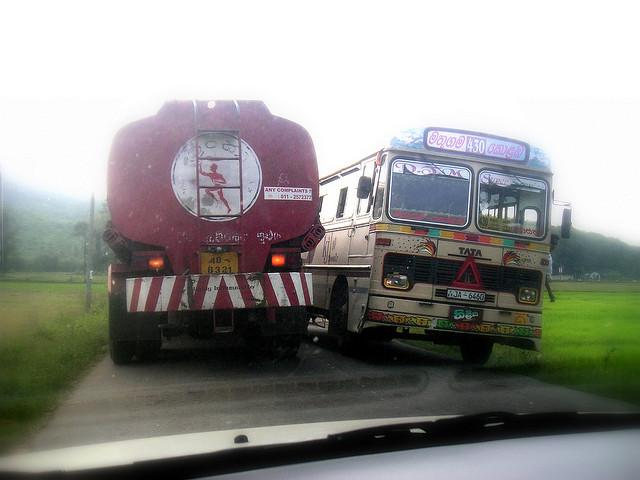Is this road wide enough for all vehicles present?
Be succinct. No. Where is the safety triangle?
Answer briefly. On bus. What is the license number?
Answer briefly. B321. Is there a ladder on the back of the truck?
Quick response, please. Yes. Is the vehicle on the left or right facing the viewer?
Answer briefly. Right. 